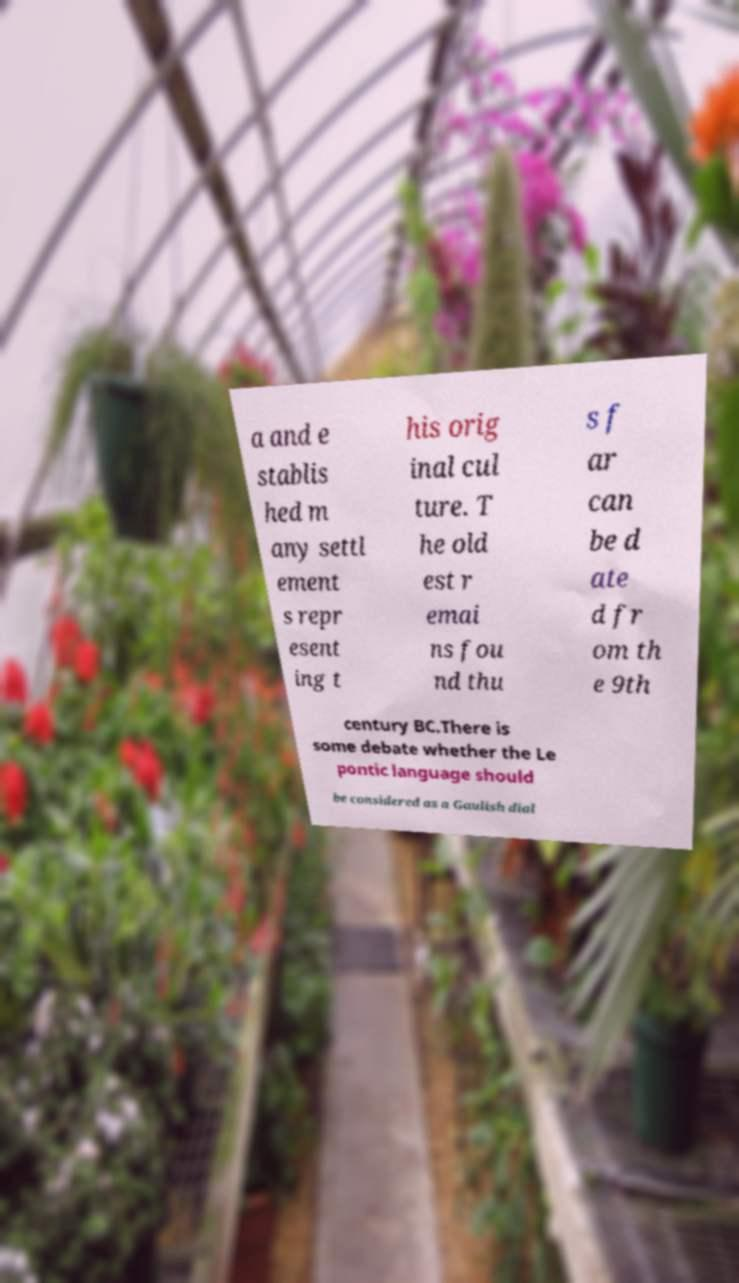Could you extract and type out the text from this image? a and e stablis hed m any settl ement s repr esent ing t his orig inal cul ture. T he old est r emai ns fou nd thu s f ar can be d ate d fr om th e 9th century BC.There is some debate whether the Le pontic language should be considered as a Gaulish dial 